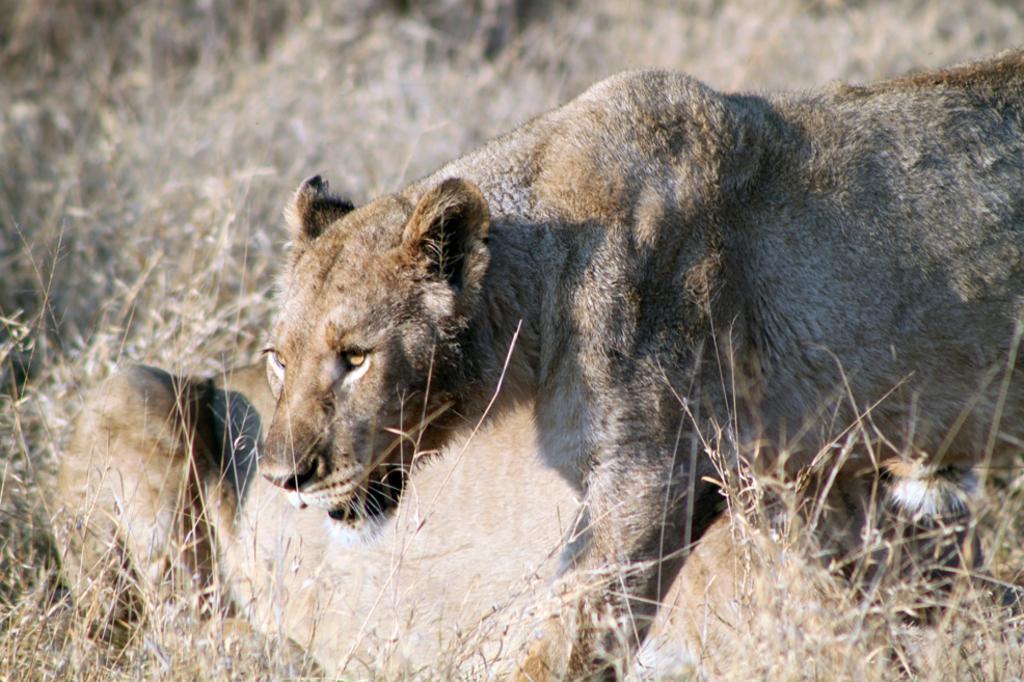Could you give a brief overview of what you see in this image? In this picture there is a tiger, beside him we can see another tiger which is lying on the ground. At the top we can see the grass. 